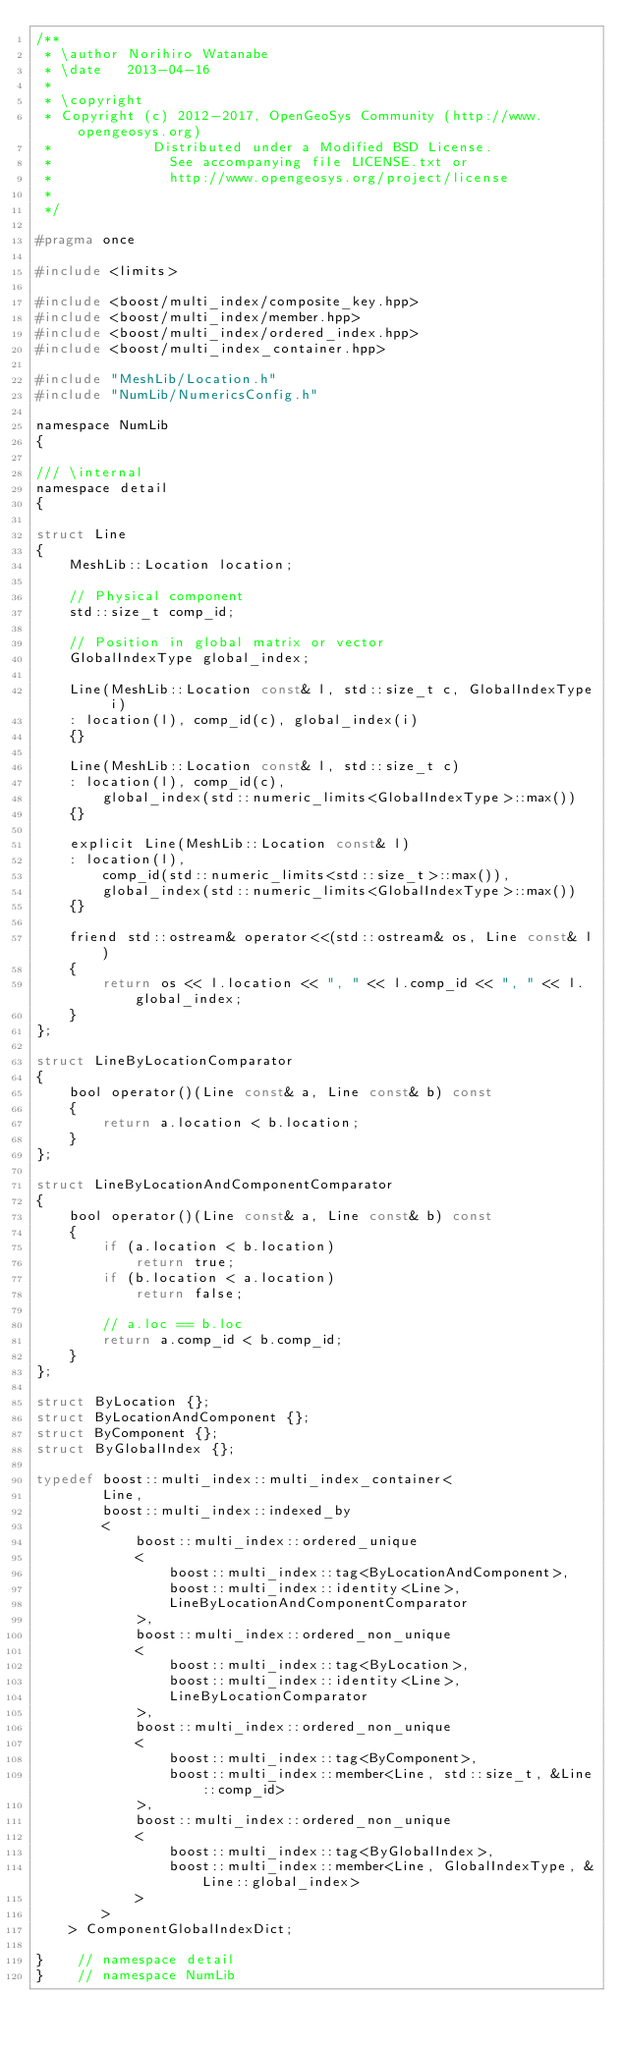<code> <loc_0><loc_0><loc_500><loc_500><_C_>/**
 * \author Norihiro Watanabe
 * \date   2013-04-16
 *
 * \copyright
 * Copyright (c) 2012-2017, OpenGeoSys Community (http://www.opengeosys.org)
 *            Distributed under a Modified BSD License.
 *              See accompanying file LICENSE.txt or
 *              http://www.opengeosys.org/project/license
 *
 */

#pragma once

#include <limits>

#include <boost/multi_index/composite_key.hpp>
#include <boost/multi_index/member.hpp>
#include <boost/multi_index/ordered_index.hpp>
#include <boost/multi_index_container.hpp>

#include "MeshLib/Location.h"
#include "NumLib/NumericsConfig.h"

namespace NumLib
{

/// \internal
namespace detail
{

struct Line
{
    MeshLib::Location location;

    // Physical component
    std::size_t comp_id;

    // Position in global matrix or vector
    GlobalIndexType global_index;

    Line(MeshLib::Location const& l, std::size_t c, GlobalIndexType i)
    : location(l), comp_id(c), global_index(i)
    {}

    Line(MeshLib::Location const& l, std::size_t c)
    : location(l), comp_id(c),
        global_index(std::numeric_limits<GlobalIndexType>::max())
    {}

    explicit Line(MeshLib::Location const& l)
    : location(l),
        comp_id(std::numeric_limits<std::size_t>::max()),
        global_index(std::numeric_limits<GlobalIndexType>::max())
    {}

    friend std::ostream& operator<<(std::ostream& os, Line const& l)
    {
        return os << l.location << ", " << l.comp_id << ", " << l.global_index;
    }
};

struct LineByLocationComparator
{
    bool operator()(Line const& a, Line const& b) const
    {
        return a.location < b.location;
    }
};

struct LineByLocationAndComponentComparator
{
    bool operator()(Line const& a, Line const& b) const
    {
        if (a.location < b.location)
            return true;
        if (b.location < a.location)
            return false;

        // a.loc == b.loc
        return a.comp_id < b.comp_id;
    }
};

struct ByLocation {};
struct ByLocationAndComponent {};
struct ByComponent {};
struct ByGlobalIndex {};

typedef boost::multi_index::multi_index_container<
        Line,
        boost::multi_index::indexed_by
        <
            boost::multi_index::ordered_unique
            <
                boost::multi_index::tag<ByLocationAndComponent>,
                boost::multi_index::identity<Line>,
                LineByLocationAndComponentComparator
            >,
            boost::multi_index::ordered_non_unique
            <
                boost::multi_index::tag<ByLocation>,
                boost::multi_index::identity<Line>,
                LineByLocationComparator
            >,
            boost::multi_index::ordered_non_unique
            <
                boost::multi_index::tag<ByComponent>,
                boost::multi_index::member<Line, std::size_t, &Line::comp_id>
            >,
            boost::multi_index::ordered_non_unique
            <
                boost::multi_index::tag<ByGlobalIndex>,
                boost::multi_index::member<Line, GlobalIndexType, &Line::global_index>
            >
        >
    > ComponentGlobalIndexDict;

}    // namespace detail
}    // namespace NumLib
</code> 